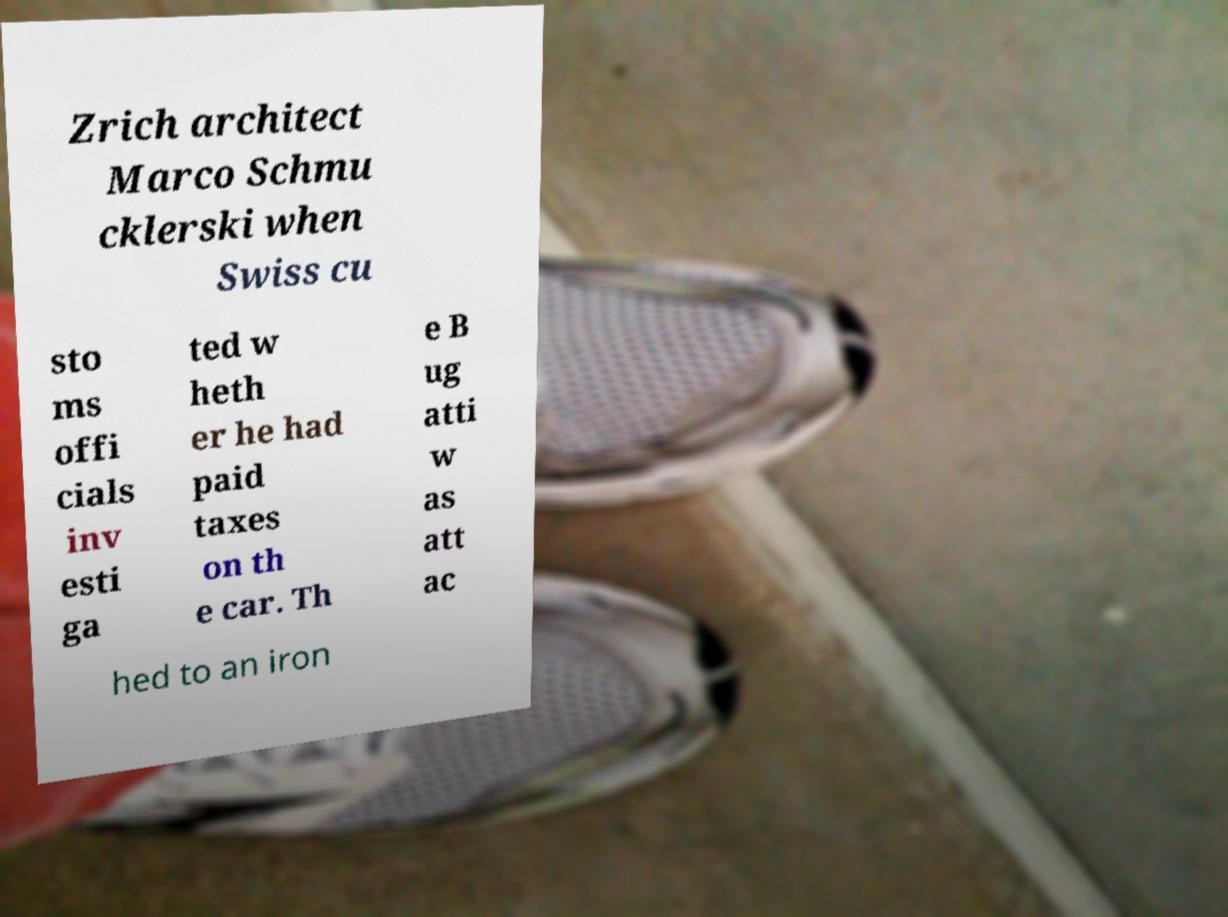What messages or text are displayed in this image? I need them in a readable, typed format. Zrich architect Marco Schmu cklerski when Swiss cu sto ms offi cials inv esti ga ted w heth er he had paid taxes on th e car. Th e B ug atti w as att ac hed to an iron 